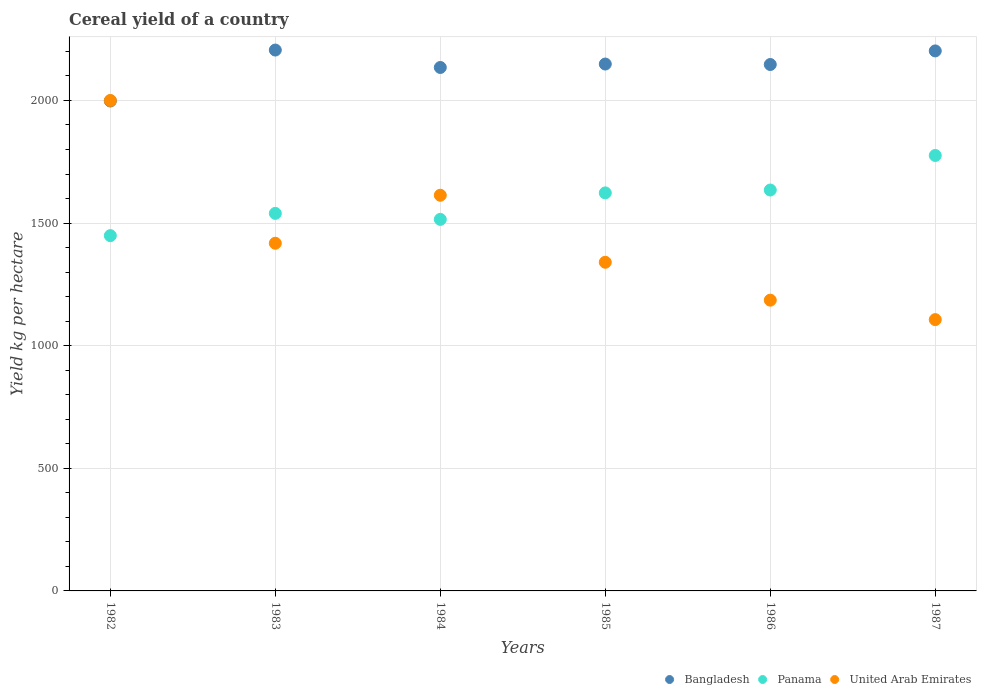Is the number of dotlines equal to the number of legend labels?
Keep it short and to the point. Yes. What is the total cereal yield in Bangladesh in 1987?
Provide a succinct answer. 2202.1. Across all years, what is the maximum total cereal yield in Panama?
Your response must be concise. 1775.69. Across all years, what is the minimum total cereal yield in Bangladesh?
Your response must be concise. 1997.9. In which year was the total cereal yield in Bangladesh maximum?
Provide a short and direct response. 1983. What is the total total cereal yield in Bangladesh in the graph?
Give a very brief answer. 1.28e+04. What is the difference between the total cereal yield in Panama in 1982 and that in 1987?
Your answer should be very brief. -326.85. What is the difference between the total cereal yield in Bangladesh in 1987 and the total cereal yield in Panama in 1982?
Offer a terse response. 753.26. What is the average total cereal yield in Panama per year?
Make the answer very short. 1589.53. In the year 1984, what is the difference between the total cereal yield in Bangladesh and total cereal yield in Panama?
Offer a very short reply. 619.49. What is the ratio of the total cereal yield in Bangladesh in 1982 to that in 1984?
Your answer should be very brief. 0.94. Is the total cereal yield in Bangladesh in 1983 less than that in 1984?
Keep it short and to the point. No. Is the difference between the total cereal yield in Bangladesh in 1982 and 1986 greater than the difference between the total cereal yield in Panama in 1982 and 1986?
Offer a terse response. Yes. What is the difference between the highest and the second highest total cereal yield in Panama?
Ensure brevity in your answer.  140.84. What is the difference between the highest and the lowest total cereal yield in Panama?
Give a very brief answer. 326.85. In how many years, is the total cereal yield in Panama greater than the average total cereal yield in Panama taken over all years?
Your answer should be compact. 3. Is the sum of the total cereal yield in Panama in 1986 and 1987 greater than the maximum total cereal yield in United Arab Emirates across all years?
Offer a terse response. Yes. Does the total cereal yield in Bangladesh monotonically increase over the years?
Offer a terse response. No. Is the total cereal yield in Bangladesh strictly greater than the total cereal yield in United Arab Emirates over the years?
Your answer should be compact. No. How many dotlines are there?
Your answer should be very brief. 3. Are the values on the major ticks of Y-axis written in scientific E-notation?
Your answer should be very brief. No. Does the graph contain grids?
Ensure brevity in your answer.  Yes. How are the legend labels stacked?
Your answer should be compact. Horizontal. What is the title of the graph?
Give a very brief answer. Cereal yield of a country. Does "Vanuatu" appear as one of the legend labels in the graph?
Make the answer very short. No. What is the label or title of the Y-axis?
Give a very brief answer. Yield kg per hectare. What is the Yield kg per hectare in Bangladesh in 1982?
Keep it short and to the point. 1997.9. What is the Yield kg per hectare of Panama in 1982?
Offer a very short reply. 1448.84. What is the Yield kg per hectare of United Arab Emirates in 1982?
Give a very brief answer. 2000. What is the Yield kg per hectare of Bangladesh in 1983?
Make the answer very short. 2205.6. What is the Yield kg per hectare in Panama in 1983?
Your answer should be compact. 1539.59. What is the Yield kg per hectare of United Arab Emirates in 1983?
Ensure brevity in your answer.  1417.78. What is the Yield kg per hectare of Bangladesh in 1984?
Offer a terse response. 2134.56. What is the Yield kg per hectare of Panama in 1984?
Provide a succinct answer. 1515.07. What is the Yield kg per hectare in United Arab Emirates in 1984?
Keep it short and to the point. 1613.44. What is the Yield kg per hectare of Bangladesh in 1985?
Make the answer very short. 2148.54. What is the Yield kg per hectare of Panama in 1985?
Your response must be concise. 1623.14. What is the Yield kg per hectare of United Arab Emirates in 1985?
Make the answer very short. 1340.21. What is the Yield kg per hectare in Bangladesh in 1986?
Keep it short and to the point. 2146.64. What is the Yield kg per hectare of Panama in 1986?
Make the answer very short. 1634.85. What is the Yield kg per hectare in United Arab Emirates in 1986?
Your answer should be compact. 1185.67. What is the Yield kg per hectare in Bangladesh in 1987?
Keep it short and to the point. 2202.1. What is the Yield kg per hectare of Panama in 1987?
Give a very brief answer. 1775.69. What is the Yield kg per hectare in United Arab Emirates in 1987?
Your response must be concise. 1106.33. Across all years, what is the maximum Yield kg per hectare of Bangladesh?
Offer a terse response. 2205.6. Across all years, what is the maximum Yield kg per hectare of Panama?
Ensure brevity in your answer.  1775.69. Across all years, what is the maximum Yield kg per hectare in United Arab Emirates?
Your answer should be compact. 2000. Across all years, what is the minimum Yield kg per hectare of Bangladesh?
Offer a very short reply. 1997.9. Across all years, what is the minimum Yield kg per hectare in Panama?
Your answer should be very brief. 1448.84. Across all years, what is the minimum Yield kg per hectare in United Arab Emirates?
Make the answer very short. 1106.33. What is the total Yield kg per hectare of Bangladesh in the graph?
Ensure brevity in your answer.  1.28e+04. What is the total Yield kg per hectare of Panama in the graph?
Your answer should be very brief. 9537.16. What is the total Yield kg per hectare in United Arab Emirates in the graph?
Offer a terse response. 8663.43. What is the difference between the Yield kg per hectare in Bangladesh in 1982 and that in 1983?
Offer a very short reply. -207.7. What is the difference between the Yield kg per hectare in Panama in 1982 and that in 1983?
Offer a very short reply. -90.76. What is the difference between the Yield kg per hectare in United Arab Emirates in 1982 and that in 1983?
Your response must be concise. 582.22. What is the difference between the Yield kg per hectare of Bangladesh in 1982 and that in 1984?
Ensure brevity in your answer.  -136.66. What is the difference between the Yield kg per hectare in Panama in 1982 and that in 1984?
Give a very brief answer. -66.23. What is the difference between the Yield kg per hectare in United Arab Emirates in 1982 and that in 1984?
Your answer should be very brief. 386.56. What is the difference between the Yield kg per hectare of Bangladesh in 1982 and that in 1985?
Offer a terse response. -150.65. What is the difference between the Yield kg per hectare of Panama in 1982 and that in 1985?
Provide a succinct answer. -174.3. What is the difference between the Yield kg per hectare in United Arab Emirates in 1982 and that in 1985?
Your answer should be very brief. 659.79. What is the difference between the Yield kg per hectare of Bangladesh in 1982 and that in 1986?
Your answer should be very brief. -148.75. What is the difference between the Yield kg per hectare in Panama in 1982 and that in 1986?
Your response must be concise. -186.01. What is the difference between the Yield kg per hectare in United Arab Emirates in 1982 and that in 1986?
Your answer should be very brief. 814.33. What is the difference between the Yield kg per hectare of Bangladesh in 1982 and that in 1987?
Provide a short and direct response. -204.2. What is the difference between the Yield kg per hectare of Panama in 1982 and that in 1987?
Offer a very short reply. -326.85. What is the difference between the Yield kg per hectare in United Arab Emirates in 1982 and that in 1987?
Provide a short and direct response. 893.67. What is the difference between the Yield kg per hectare of Bangladesh in 1983 and that in 1984?
Your response must be concise. 71.04. What is the difference between the Yield kg per hectare in Panama in 1983 and that in 1984?
Provide a succinct answer. 24.52. What is the difference between the Yield kg per hectare in United Arab Emirates in 1983 and that in 1984?
Your response must be concise. -195.67. What is the difference between the Yield kg per hectare in Bangladesh in 1983 and that in 1985?
Your response must be concise. 57.06. What is the difference between the Yield kg per hectare in Panama in 1983 and that in 1985?
Provide a short and direct response. -83.55. What is the difference between the Yield kg per hectare in United Arab Emirates in 1983 and that in 1985?
Give a very brief answer. 77.57. What is the difference between the Yield kg per hectare of Bangladesh in 1983 and that in 1986?
Give a very brief answer. 58.96. What is the difference between the Yield kg per hectare of Panama in 1983 and that in 1986?
Ensure brevity in your answer.  -95.25. What is the difference between the Yield kg per hectare in United Arab Emirates in 1983 and that in 1986?
Keep it short and to the point. 232.11. What is the difference between the Yield kg per hectare of Panama in 1983 and that in 1987?
Give a very brief answer. -236.09. What is the difference between the Yield kg per hectare of United Arab Emirates in 1983 and that in 1987?
Offer a terse response. 311.45. What is the difference between the Yield kg per hectare of Bangladesh in 1984 and that in 1985?
Provide a short and direct response. -13.98. What is the difference between the Yield kg per hectare of Panama in 1984 and that in 1985?
Offer a terse response. -108.07. What is the difference between the Yield kg per hectare of United Arab Emirates in 1984 and that in 1985?
Offer a very short reply. 273.24. What is the difference between the Yield kg per hectare in Bangladesh in 1984 and that in 1986?
Give a very brief answer. -12.08. What is the difference between the Yield kg per hectare in Panama in 1984 and that in 1986?
Offer a very short reply. -119.78. What is the difference between the Yield kg per hectare in United Arab Emirates in 1984 and that in 1986?
Your answer should be very brief. 427.77. What is the difference between the Yield kg per hectare of Bangladesh in 1984 and that in 1987?
Give a very brief answer. -67.54. What is the difference between the Yield kg per hectare of Panama in 1984 and that in 1987?
Offer a terse response. -260.62. What is the difference between the Yield kg per hectare of United Arab Emirates in 1984 and that in 1987?
Offer a terse response. 507.12. What is the difference between the Yield kg per hectare in Bangladesh in 1985 and that in 1986?
Your response must be concise. 1.9. What is the difference between the Yield kg per hectare of Panama in 1985 and that in 1986?
Ensure brevity in your answer.  -11.71. What is the difference between the Yield kg per hectare of United Arab Emirates in 1985 and that in 1986?
Your response must be concise. 154.53. What is the difference between the Yield kg per hectare of Bangladesh in 1985 and that in 1987?
Keep it short and to the point. -53.56. What is the difference between the Yield kg per hectare in Panama in 1985 and that in 1987?
Your response must be concise. -152.55. What is the difference between the Yield kg per hectare of United Arab Emirates in 1985 and that in 1987?
Your answer should be compact. 233.88. What is the difference between the Yield kg per hectare in Bangladesh in 1986 and that in 1987?
Provide a short and direct response. -55.46. What is the difference between the Yield kg per hectare in Panama in 1986 and that in 1987?
Make the answer very short. -140.84. What is the difference between the Yield kg per hectare of United Arab Emirates in 1986 and that in 1987?
Offer a terse response. 79.34. What is the difference between the Yield kg per hectare in Bangladesh in 1982 and the Yield kg per hectare in Panama in 1983?
Make the answer very short. 458.31. What is the difference between the Yield kg per hectare in Bangladesh in 1982 and the Yield kg per hectare in United Arab Emirates in 1983?
Your response must be concise. 580.12. What is the difference between the Yield kg per hectare in Panama in 1982 and the Yield kg per hectare in United Arab Emirates in 1983?
Ensure brevity in your answer.  31.06. What is the difference between the Yield kg per hectare in Bangladesh in 1982 and the Yield kg per hectare in Panama in 1984?
Your response must be concise. 482.83. What is the difference between the Yield kg per hectare in Bangladesh in 1982 and the Yield kg per hectare in United Arab Emirates in 1984?
Make the answer very short. 384.45. What is the difference between the Yield kg per hectare in Panama in 1982 and the Yield kg per hectare in United Arab Emirates in 1984?
Provide a succinct answer. -164.61. What is the difference between the Yield kg per hectare of Bangladesh in 1982 and the Yield kg per hectare of Panama in 1985?
Offer a very short reply. 374.76. What is the difference between the Yield kg per hectare of Bangladesh in 1982 and the Yield kg per hectare of United Arab Emirates in 1985?
Your answer should be very brief. 657.69. What is the difference between the Yield kg per hectare in Panama in 1982 and the Yield kg per hectare in United Arab Emirates in 1985?
Make the answer very short. 108.63. What is the difference between the Yield kg per hectare in Bangladesh in 1982 and the Yield kg per hectare in Panama in 1986?
Make the answer very short. 363.05. What is the difference between the Yield kg per hectare in Bangladesh in 1982 and the Yield kg per hectare in United Arab Emirates in 1986?
Keep it short and to the point. 812.23. What is the difference between the Yield kg per hectare in Panama in 1982 and the Yield kg per hectare in United Arab Emirates in 1986?
Provide a succinct answer. 263.16. What is the difference between the Yield kg per hectare in Bangladesh in 1982 and the Yield kg per hectare in Panama in 1987?
Your answer should be very brief. 222.21. What is the difference between the Yield kg per hectare in Bangladesh in 1982 and the Yield kg per hectare in United Arab Emirates in 1987?
Your answer should be compact. 891.57. What is the difference between the Yield kg per hectare of Panama in 1982 and the Yield kg per hectare of United Arab Emirates in 1987?
Provide a short and direct response. 342.51. What is the difference between the Yield kg per hectare in Bangladesh in 1983 and the Yield kg per hectare in Panama in 1984?
Provide a succinct answer. 690.53. What is the difference between the Yield kg per hectare of Bangladesh in 1983 and the Yield kg per hectare of United Arab Emirates in 1984?
Give a very brief answer. 592.15. What is the difference between the Yield kg per hectare in Panama in 1983 and the Yield kg per hectare in United Arab Emirates in 1984?
Make the answer very short. -73.85. What is the difference between the Yield kg per hectare in Bangladesh in 1983 and the Yield kg per hectare in Panama in 1985?
Provide a short and direct response. 582.46. What is the difference between the Yield kg per hectare in Bangladesh in 1983 and the Yield kg per hectare in United Arab Emirates in 1985?
Offer a very short reply. 865.39. What is the difference between the Yield kg per hectare of Panama in 1983 and the Yield kg per hectare of United Arab Emirates in 1985?
Your answer should be compact. 199.39. What is the difference between the Yield kg per hectare in Bangladesh in 1983 and the Yield kg per hectare in Panama in 1986?
Offer a very short reply. 570.75. What is the difference between the Yield kg per hectare in Bangladesh in 1983 and the Yield kg per hectare in United Arab Emirates in 1986?
Provide a short and direct response. 1019.93. What is the difference between the Yield kg per hectare of Panama in 1983 and the Yield kg per hectare of United Arab Emirates in 1986?
Your response must be concise. 353.92. What is the difference between the Yield kg per hectare in Bangladesh in 1983 and the Yield kg per hectare in Panama in 1987?
Give a very brief answer. 429.91. What is the difference between the Yield kg per hectare of Bangladesh in 1983 and the Yield kg per hectare of United Arab Emirates in 1987?
Keep it short and to the point. 1099.27. What is the difference between the Yield kg per hectare of Panama in 1983 and the Yield kg per hectare of United Arab Emirates in 1987?
Ensure brevity in your answer.  433.26. What is the difference between the Yield kg per hectare in Bangladesh in 1984 and the Yield kg per hectare in Panama in 1985?
Offer a very short reply. 511.42. What is the difference between the Yield kg per hectare in Bangladesh in 1984 and the Yield kg per hectare in United Arab Emirates in 1985?
Provide a short and direct response. 794.35. What is the difference between the Yield kg per hectare of Panama in 1984 and the Yield kg per hectare of United Arab Emirates in 1985?
Offer a terse response. 174.86. What is the difference between the Yield kg per hectare of Bangladesh in 1984 and the Yield kg per hectare of Panama in 1986?
Offer a very short reply. 499.71. What is the difference between the Yield kg per hectare of Bangladesh in 1984 and the Yield kg per hectare of United Arab Emirates in 1986?
Make the answer very short. 948.89. What is the difference between the Yield kg per hectare of Panama in 1984 and the Yield kg per hectare of United Arab Emirates in 1986?
Your answer should be very brief. 329.4. What is the difference between the Yield kg per hectare of Bangladesh in 1984 and the Yield kg per hectare of Panama in 1987?
Keep it short and to the point. 358.87. What is the difference between the Yield kg per hectare in Bangladesh in 1984 and the Yield kg per hectare in United Arab Emirates in 1987?
Keep it short and to the point. 1028.23. What is the difference between the Yield kg per hectare of Panama in 1984 and the Yield kg per hectare of United Arab Emirates in 1987?
Keep it short and to the point. 408.74. What is the difference between the Yield kg per hectare in Bangladesh in 1985 and the Yield kg per hectare in Panama in 1986?
Keep it short and to the point. 513.7. What is the difference between the Yield kg per hectare of Bangladesh in 1985 and the Yield kg per hectare of United Arab Emirates in 1986?
Offer a very short reply. 962.87. What is the difference between the Yield kg per hectare in Panama in 1985 and the Yield kg per hectare in United Arab Emirates in 1986?
Ensure brevity in your answer.  437.47. What is the difference between the Yield kg per hectare in Bangladesh in 1985 and the Yield kg per hectare in Panama in 1987?
Provide a succinct answer. 372.86. What is the difference between the Yield kg per hectare of Bangladesh in 1985 and the Yield kg per hectare of United Arab Emirates in 1987?
Offer a terse response. 1042.21. What is the difference between the Yield kg per hectare of Panama in 1985 and the Yield kg per hectare of United Arab Emirates in 1987?
Your response must be concise. 516.81. What is the difference between the Yield kg per hectare in Bangladesh in 1986 and the Yield kg per hectare in Panama in 1987?
Offer a terse response. 370.95. What is the difference between the Yield kg per hectare of Bangladesh in 1986 and the Yield kg per hectare of United Arab Emirates in 1987?
Offer a terse response. 1040.31. What is the difference between the Yield kg per hectare in Panama in 1986 and the Yield kg per hectare in United Arab Emirates in 1987?
Provide a short and direct response. 528.52. What is the average Yield kg per hectare in Bangladesh per year?
Give a very brief answer. 2139.22. What is the average Yield kg per hectare of Panama per year?
Give a very brief answer. 1589.53. What is the average Yield kg per hectare in United Arab Emirates per year?
Offer a very short reply. 1443.9. In the year 1982, what is the difference between the Yield kg per hectare of Bangladesh and Yield kg per hectare of Panama?
Ensure brevity in your answer.  549.06. In the year 1982, what is the difference between the Yield kg per hectare of Bangladesh and Yield kg per hectare of United Arab Emirates?
Provide a short and direct response. -2.1. In the year 1982, what is the difference between the Yield kg per hectare of Panama and Yield kg per hectare of United Arab Emirates?
Offer a terse response. -551.16. In the year 1983, what is the difference between the Yield kg per hectare in Bangladesh and Yield kg per hectare in Panama?
Provide a short and direct response. 666.01. In the year 1983, what is the difference between the Yield kg per hectare in Bangladesh and Yield kg per hectare in United Arab Emirates?
Keep it short and to the point. 787.82. In the year 1983, what is the difference between the Yield kg per hectare in Panama and Yield kg per hectare in United Arab Emirates?
Make the answer very short. 121.81. In the year 1984, what is the difference between the Yield kg per hectare of Bangladesh and Yield kg per hectare of Panama?
Offer a terse response. 619.49. In the year 1984, what is the difference between the Yield kg per hectare in Bangladesh and Yield kg per hectare in United Arab Emirates?
Give a very brief answer. 521.11. In the year 1984, what is the difference between the Yield kg per hectare of Panama and Yield kg per hectare of United Arab Emirates?
Offer a very short reply. -98.38. In the year 1985, what is the difference between the Yield kg per hectare in Bangladesh and Yield kg per hectare in Panama?
Make the answer very short. 525.41. In the year 1985, what is the difference between the Yield kg per hectare in Bangladesh and Yield kg per hectare in United Arab Emirates?
Make the answer very short. 808.34. In the year 1985, what is the difference between the Yield kg per hectare in Panama and Yield kg per hectare in United Arab Emirates?
Offer a very short reply. 282.93. In the year 1986, what is the difference between the Yield kg per hectare in Bangladesh and Yield kg per hectare in Panama?
Keep it short and to the point. 511.8. In the year 1986, what is the difference between the Yield kg per hectare in Bangladesh and Yield kg per hectare in United Arab Emirates?
Provide a succinct answer. 960.97. In the year 1986, what is the difference between the Yield kg per hectare of Panama and Yield kg per hectare of United Arab Emirates?
Ensure brevity in your answer.  449.18. In the year 1987, what is the difference between the Yield kg per hectare of Bangladesh and Yield kg per hectare of Panama?
Offer a terse response. 426.41. In the year 1987, what is the difference between the Yield kg per hectare in Bangladesh and Yield kg per hectare in United Arab Emirates?
Your response must be concise. 1095.77. In the year 1987, what is the difference between the Yield kg per hectare in Panama and Yield kg per hectare in United Arab Emirates?
Ensure brevity in your answer.  669.36. What is the ratio of the Yield kg per hectare in Bangladesh in 1982 to that in 1983?
Give a very brief answer. 0.91. What is the ratio of the Yield kg per hectare in Panama in 1982 to that in 1983?
Make the answer very short. 0.94. What is the ratio of the Yield kg per hectare in United Arab Emirates in 1982 to that in 1983?
Provide a short and direct response. 1.41. What is the ratio of the Yield kg per hectare of Bangladesh in 1982 to that in 1984?
Ensure brevity in your answer.  0.94. What is the ratio of the Yield kg per hectare of Panama in 1982 to that in 1984?
Give a very brief answer. 0.96. What is the ratio of the Yield kg per hectare of United Arab Emirates in 1982 to that in 1984?
Provide a short and direct response. 1.24. What is the ratio of the Yield kg per hectare of Bangladesh in 1982 to that in 1985?
Provide a succinct answer. 0.93. What is the ratio of the Yield kg per hectare of Panama in 1982 to that in 1985?
Provide a short and direct response. 0.89. What is the ratio of the Yield kg per hectare in United Arab Emirates in 1982 to that in 1985?
Provide a succinct answer. 1.49. What is the ratio of the Yield kg per hectare of Bangladesh in 1982 to that in 1986?
Make the answer very short. 0.93. What is the ratio of the Yield kg per hectare in Panama in 1982 to that in 1986?
Make the answer very short. 0.89. What is the ratio of the Yield kg per hectare of United Arab Emirates in 1982 to that in 1986?
Offer a terse response. 1.69. What is the ratio of the Yield kg per hectare of Bangladesh in 1982 to that in 1987?
Give a very brief answer. 0.91. What is the ratio of the Yield kg per hectare in Panama in 1982 to that in 1987?
Give a very brief answer. 0.82. What is the ratio of the Yield kg per hectare in United Arab Emirates in 1982 to that in 1987?
Your answer should be very brief. 1.81. What is the ratio of the Yield kg per hectare in Bangladesh in 1983 to that in 1984?
Your answer should be compact. 1.03. What is the ratio of the Yield kg per hectare of Panama in 1983 to that in 1984?
Your response must be concise. 1.02. What is the ratio of the Yield kg per hectare of United Arab Emirates in 1983 to that in 1984?
Your response must be concise. 0.88. What is the ratio of the Yield kg per hectare in Bangladesh in 1983 to that in 1985?
Offer a terse response. 1.03. What is the ratio of the Yield kg per hectare of Panama in 1983 to that in 1985?
Offer a terse response. 0.95. What is the ratio of the Yield kg per hectare of United Arab Emirates in 1983 to that in 1985?
Offer a very short reply. 1.06. What is the ratio of the Yield kg per hectare of Bangladesh in 1983 to that in 1986?
Your answer should be compact. 1.03. What is the ratio of the Yield kg per hectare in Panama in 1983 to that in 1986?
Ensure brevity in your answer.  0.94. What is the ratio of the Yield kg per hectare in United Arab Emirates in 1983 to that in 1986?
Offer a terse response. 1.2. What is the ratio of the Yield kg per hectare of Bangladesh in 1983 to that in 1987?
Offer a terse response. 1. What is the ratio of the Yield kg per hectare of Panama in 1983 to that in 1987?
Give a very brief answer. 0.87. What is the ratio of the Yield kg per hectare of United Arab Emirates in 1983 to that in 1987?
Offer a terse response. 1.28. What is the ratio of the Yield kg per hectare of Panama in 1984 to that in 1985?
Your answer should be very brief. 0.93. What is the ratio of the Yield kg per hectare of United Arab Emirates in 1984 to that in 1985?
Your response must be concise. 1.2. What is the ratio of the Yield kg per hectare in Panama in 1984 to that in 1986?
Keep it short and to the point. 0.93. What is the ratio of the Yield kg per hectare of United Arab Emirates in 1984 to that in 1986?
Keep it short and to the point. 1.36. What is the ratio of the Yield kg per hectare of Bangladesh in 1984 to that in 1987?
Provide a short and direct response. 0.97. What is the ratio of the Yield kg per hectare in Panama in 1984 to that in 1987?
Make the answer very short. 0.85. What is the ratio of the Yield kg per hectare in United Arab Emirates in 1984 to that in 1987?
Make the answer very short. 1.46. What is the ratio of the Yield kg per hectare of Bangladesh in 1985 to that in 1986?
Keep it short and to the point. 1. What is the ratio of the Yield kg per hectare of United Arab Emirates in 1985 to that in 1986?
Provide a short and direct response. 1.13. What is the ratio of the Yield kg per hectare in Bangladesh in 1985 to that in 1987?
Give a very brief answer. 0.98. What is the ratio of the Yield kg per hectare of Panama in 1985 to that in 1987?
Provide a succinct answer. 0.91. What is the ratio of the Yield kg per hectare in United Arab Emirates in 1985 to that in 1987?
Your answer should be compact. 1.21. What is the ratio of the Yield kg per hectare in Bangladesh in 1986 to that in 1987?
Keep it short and to the point. 0.97. What is the ratio of the Yield kg per hectare in Panama in 1986 to that in 1987?
Your answer should be compact. 0.92. What is the ratio of the Yield kg per hectare of United Arab Emirates in 1986 to that in 1987?
Give a very brief answer. 1.07. What is the difference between the highest and the second highest Yield kg per hectare in Bangladesh?
Your answer should be very brief. 3.5. What is the difference between the highest and the second highest Yield kg per hectare in Panama?
Provide a succinct answer. 140.84. What is the difference between the highest and the second highest Yield kg per hectare in United Arab Emirates?
Give a very brief answer. 386.56. What is the difference between the highest and the lowest Yield kg per hectare of Bangladesh?
Provide a succinct answer. 207.7. What is the difference between the highest and the lowest Yield kg per hectare in Panama?
Your answer should be compact. 326.85. What is the difference between the highest and the lowest Yield kg per hectare of United Arab Emirates?
Offer a terse response. 893.67. 